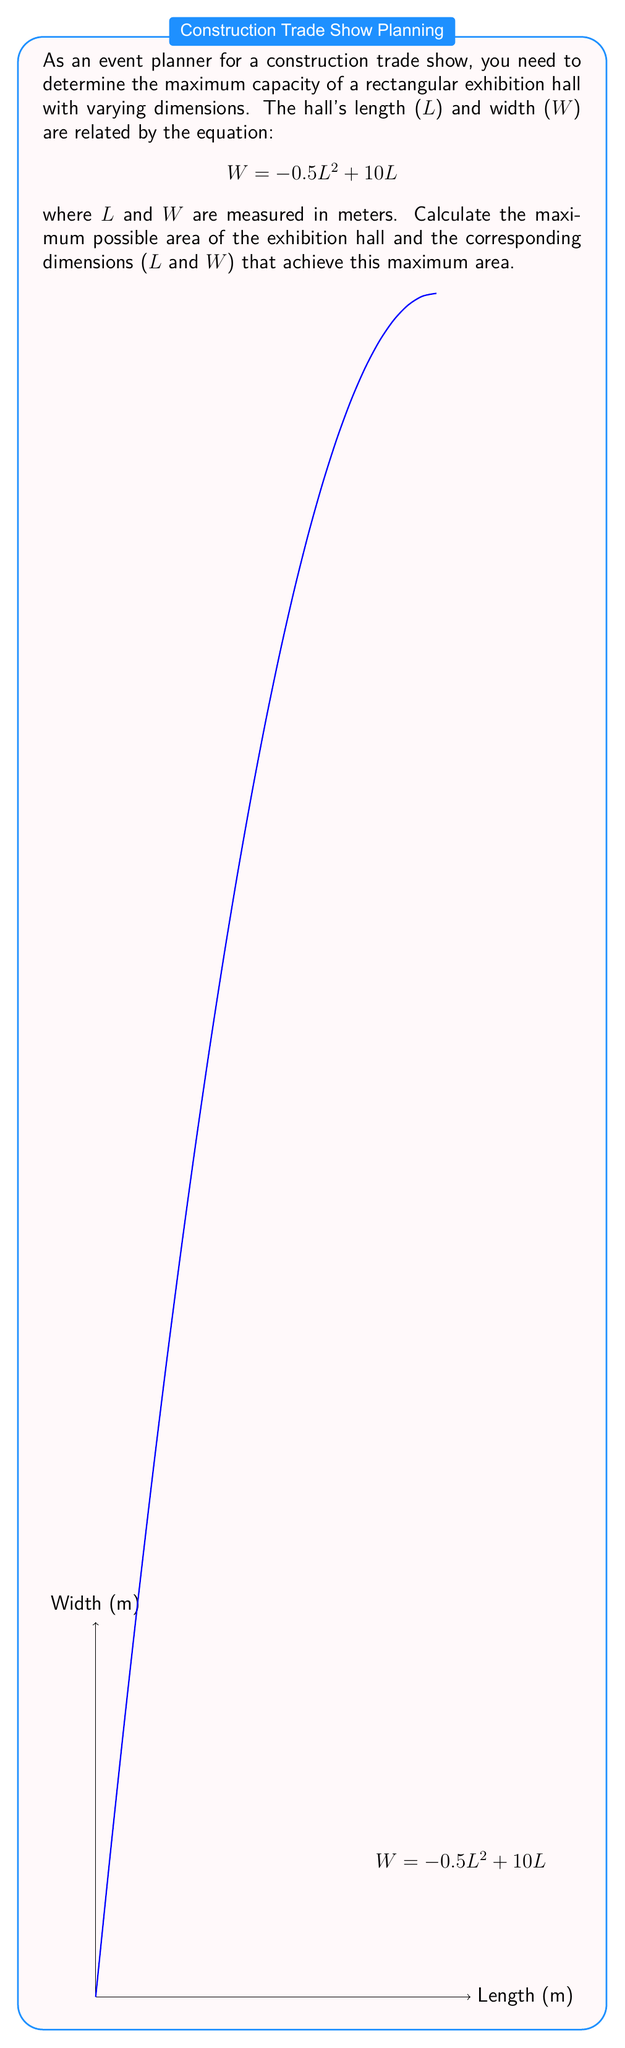Can you solve this math problem? Let's approach this step-by-step:

1) The area (A) of a rectangular hall is given by $A = L \times W$.

2) Substituting the given equation for W:
   $A = L \times (-0.5L^2 + 10L) = -0.5L^3 + 10L^2$

3) To find the maximum area, we need to differentiate A with respect to L and set it to zero:
   $\frac{dA}{dL} = -1.5L^2 + 20L$

4) Set this equal to zero:
   $-1.5L^2 + 20L = 0$

5) Factor out L:
   $L(-1.5L + 20) = 0$

6) Solve for L:
   $L = 0$ or $-1.5L + 20 = 0$
   $L = 0$ or $L = \frac{20}{1.5} = 13.33$ meters

7) L = 0 gives minimum area (0), so the maximum occurs at L ≈ 13.33 meters.

8) Calculate W when L ≈ 13.33:
   $W = -0.5(13.33)^2 + 10(13.33) ≈ 66.65 - 133.3 = 66.65$ meters

9) Calculate the maximum area:
   $A_{max} = 13.33 \times 66.65 ≈ 888.44$ square meters
Answer: Maximum area: 888.44 m²; Dimensions: L ≈ 13.33 m, W ≈ 66.65 m 